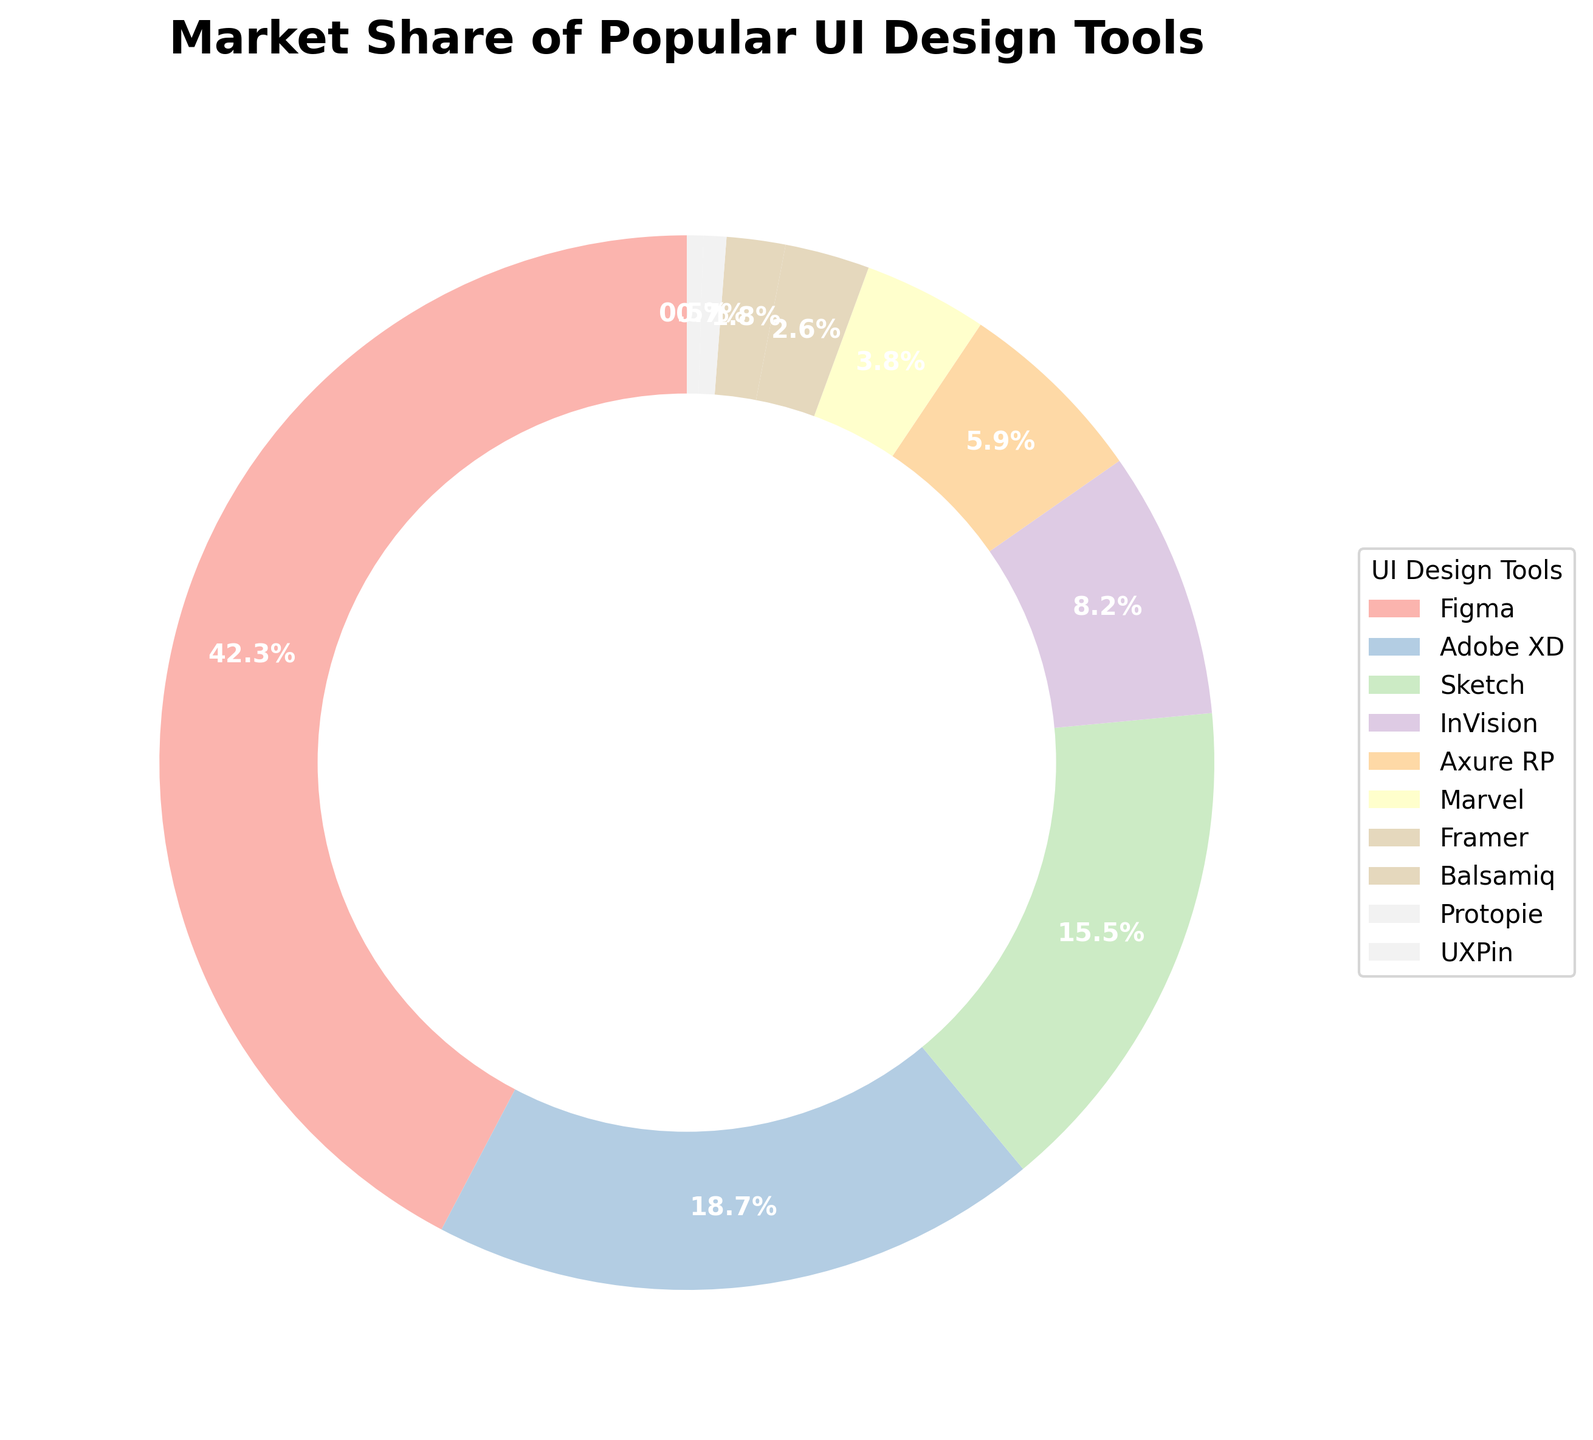What's the total market share of Adobe XD and Sketch? To find the total market share of Adobe XD and Sketch, sum their market shares: Adobe XD (18.7%) + Sketch (15.5%) = 34.2%
Answer: 34.2% Which tool has the smallest market share? To find the smallest market share, look for the tool with the lowest percentage on the pie chart, which is UXPin with 0.5%
Answer: UXPin Is the market share of Figma more than double that of Sketch? Compare the market shares of Figma and Sketch to see if Figma's is more than double Sketch's. Figma (42.3%) is more than double Sketch (15.5%) because 2 * 15.5% = 31% and 42.3% > 31%
Answer: Yes What is the combined market share of the tools with less than 5% individually? Identify the tools with less than 5% market share (Marvel, Framer, Balsamiq, Protopie, UXPin) and sum their market shares: 3.8% + 2.6% + 1.8% + 0.7% + 0.5% = 9.4%
Answer: 9.4% Which tool has a market share closest to 10% and what is that share? Look for the tool with a market share nearest to 10%. The closest is InVision with 8.2%
Answer: InVision, 8.2% What percentage of the market do the three leading tools (Figma, Adobe XD, and Sketch) occupy together? Add the market shares of the top three tools: Figma (42.3%) + Adobe XD (18.7%) + Sketch (15.5%). The total is 42.3% + 18.7% + 15.5% = 76.5%
Answer: 76.5% How many more percentage points does Figma have compared to InVision? Subtract InVision’s market share from Figma’s: 42.3% - 8.2% = 34.1%
Answer: 34.1% Which color represents Axure RP, and what is its market share? In the legend, the color corresponding to Axure RP should be identified; Axure RP has a market share of 5.9%. (Assuming Axure RP's color is pastel blue based on the custom colors in the chart)
Answer: Pastel blue, 5.9% Is the market share of Marvel greater than that of Framer and Balsamiq combined? Compare Marvel's market share (3.8%) with the combined market share of Framer (2.6%) and Balsamiq (1.8%): 2.6% + 1.8% = 4.4%. Since 3.8% < 4.4%, Marvel's market share is not greater
Answer: No What is the difference between the tool with the highest and the tool with the lowest market share? Subtract the smallest market share (UXPin, 0.5%) from the largest market share (Figma, 42.3%): 42.3% - 0.5% = 41.8%
Answer: 41.8% 